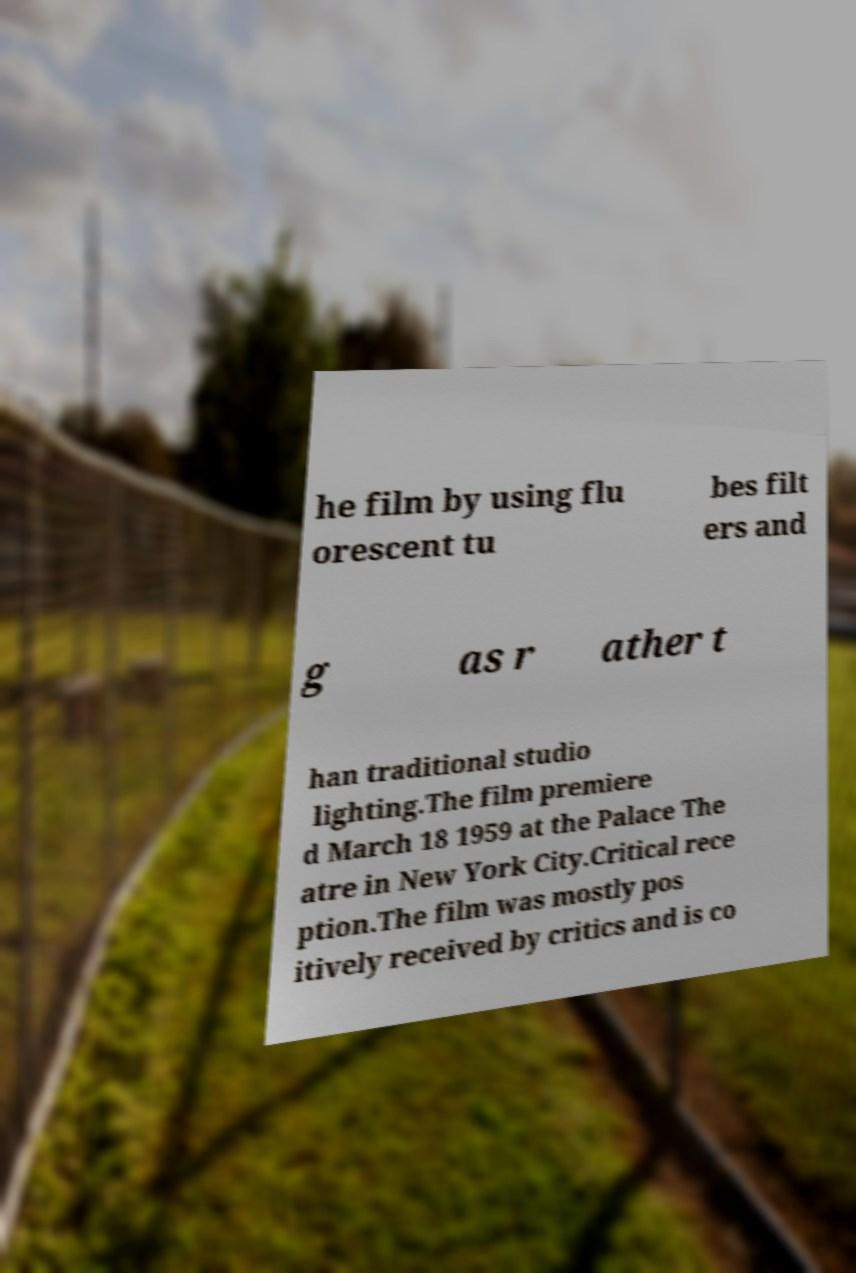There's text embedded in this image that I need extracted. Can you transcribe it verbatim? he film by using flu orescent tu bes filt ers and g as r ather t han traditional studio lighting.The film premiere d March 18 1959 at the Palace The atre in New York City.Critical rece ption.The film was mostly pos itively received by critics and is co 